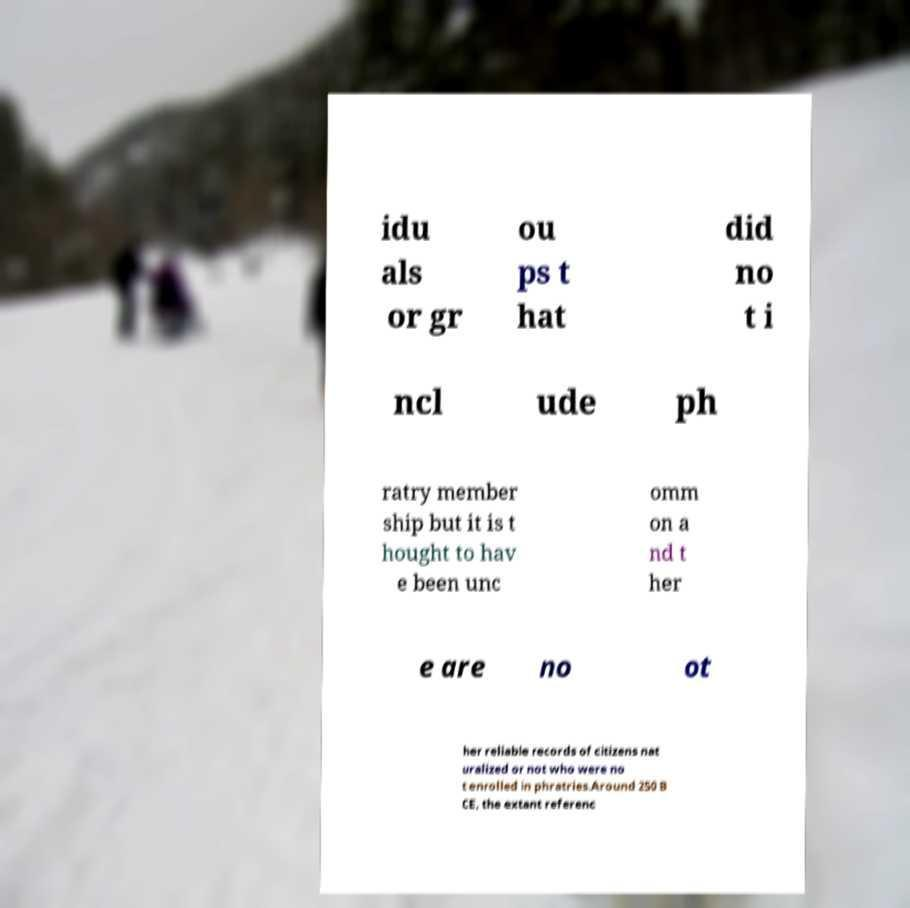Could you assist in decoding the text presented in this image and type it out clearly? idu als or gr ou ps t hat did no t i ncl ude ph ratry member ship but it is t hought to hav e been unc omm on a nd t her e are no ot her reliable records of citizens nat uralized or not who were no t enrolled in phratries.Around 250 B CE, the extant referenc 